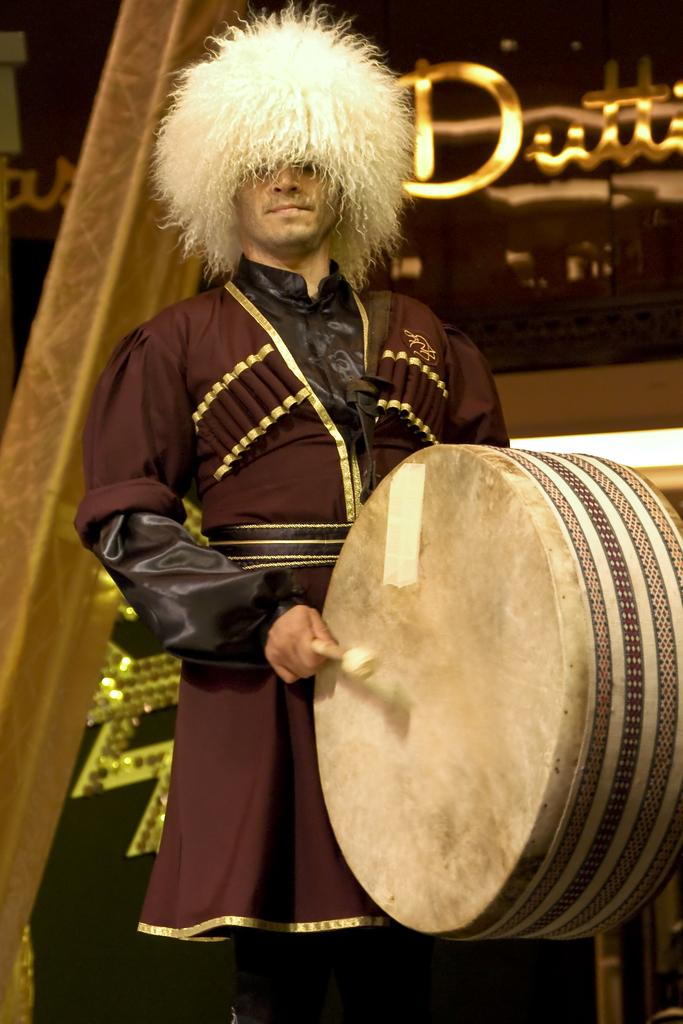Who is the main subject in the image? There is a man in the center of the image. What is the man doing in the image? The man is standing and drumming. What can be seen in the background of the image? There are lights and text written in the background of the image. Can you tell me how the man is fulfilling the self-request in the image? There is no mention of a self-request in the image, as the man is simply standing and drumming. 